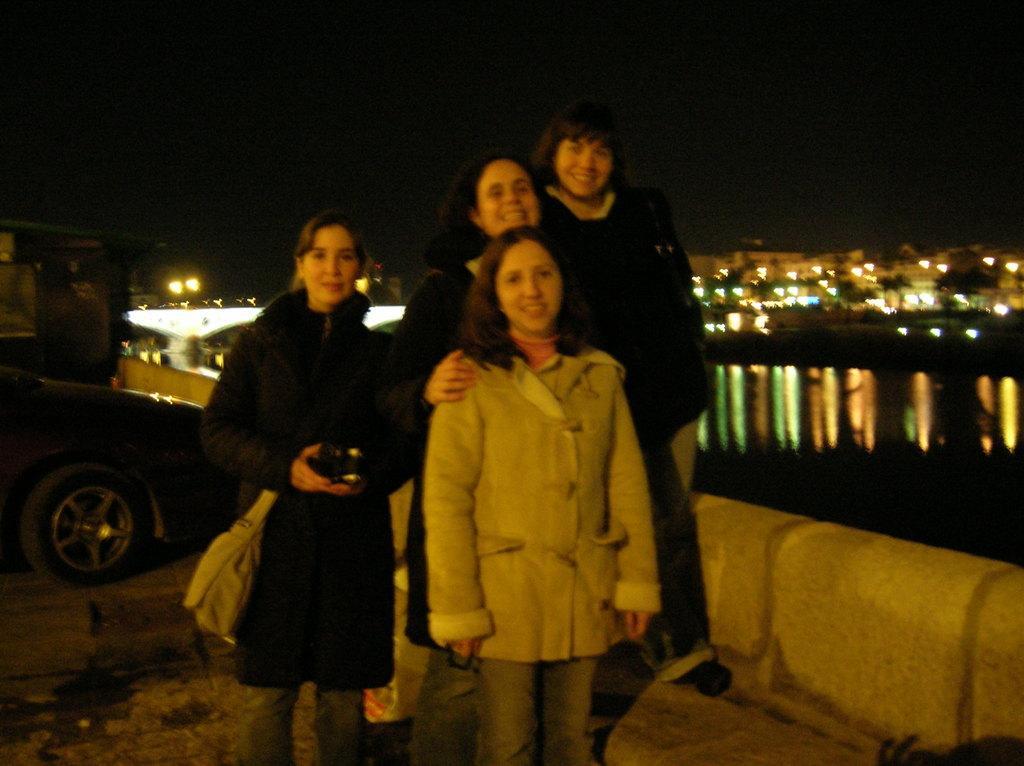Please provide a concise description of this image. This picture is taken during the night time. In this image there are four persons standing on the floor. The woman on the left side is holding the camera and a bag. In the background there is water, behind the water there are so many buildings with the lights. On the left side there is a vehicle. 